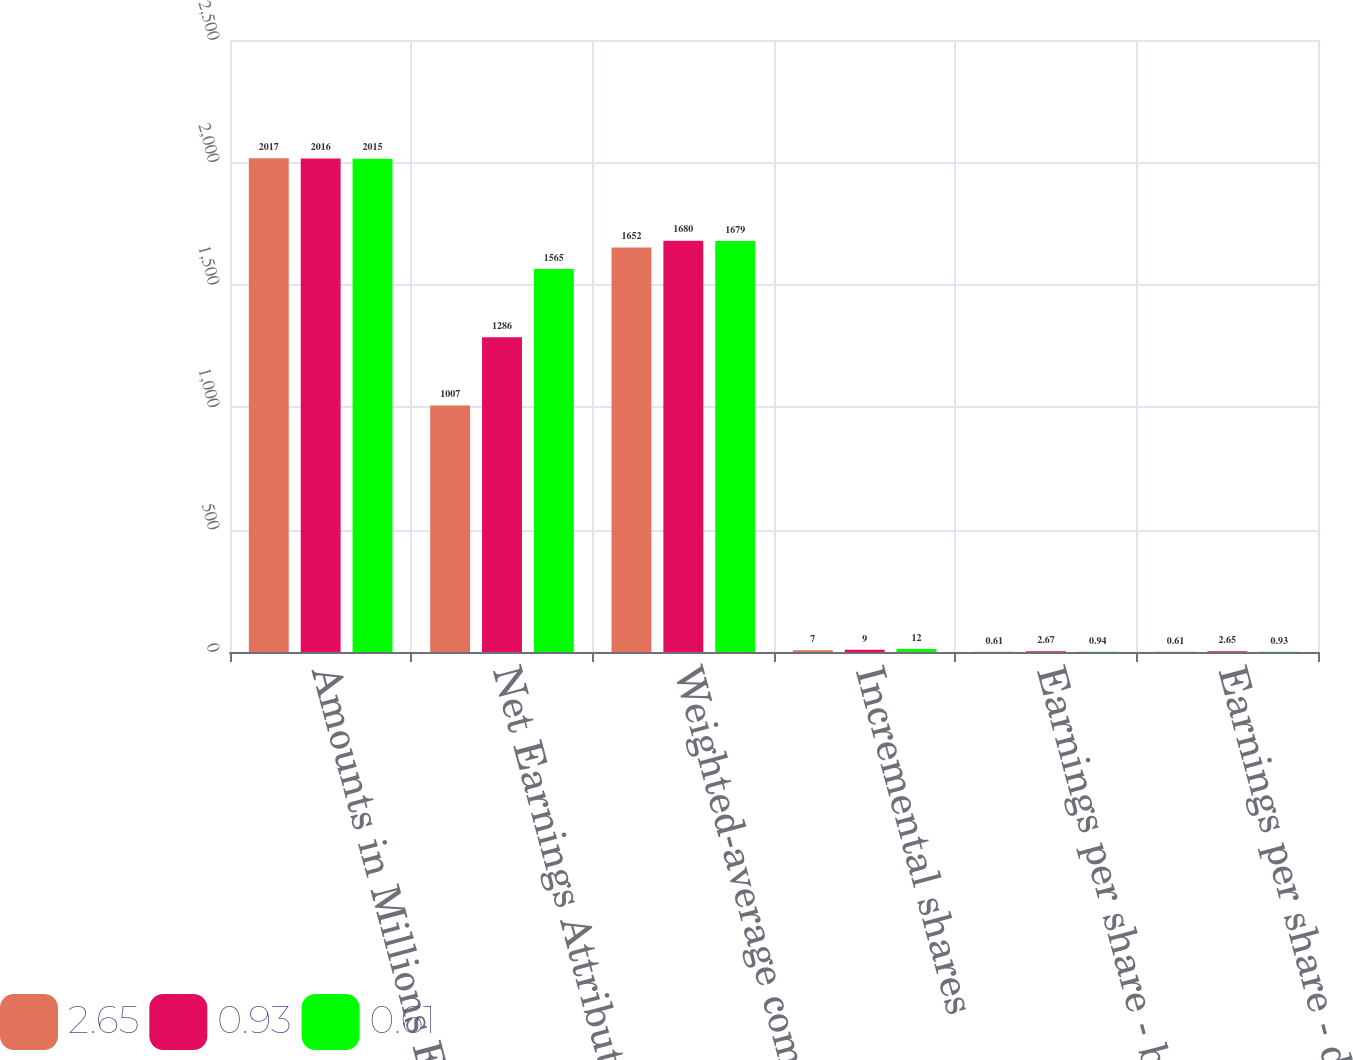Convert chart. <chart><loc_0><loc_0><loc_500><loc_500><stacked_bar_chart><ecel><fcel>Amounts in Millions Except Per<fcel>Net Earnings Attributable to<fcel>Weighted-average common shares<fcel>Incremental shares<fcel>Earnings per share - basic<fcel>Earnings per share - diluted<nl><fcel>2.65<fcel>2017<fcel>1007<fcel>1652<fcel>7<fcel>0.61<fcel>0.61<nl><fcel>0.93<fcel>2016<fcel>1286<fcel>1680<fcel>9<fcel>2.67<fcel>2.65<nl><fcel>0.61<fcel>2015<fcel>1565<fcel>1679<fcel>12<fcel>0.94<fcel>0.93<nl></chart> 